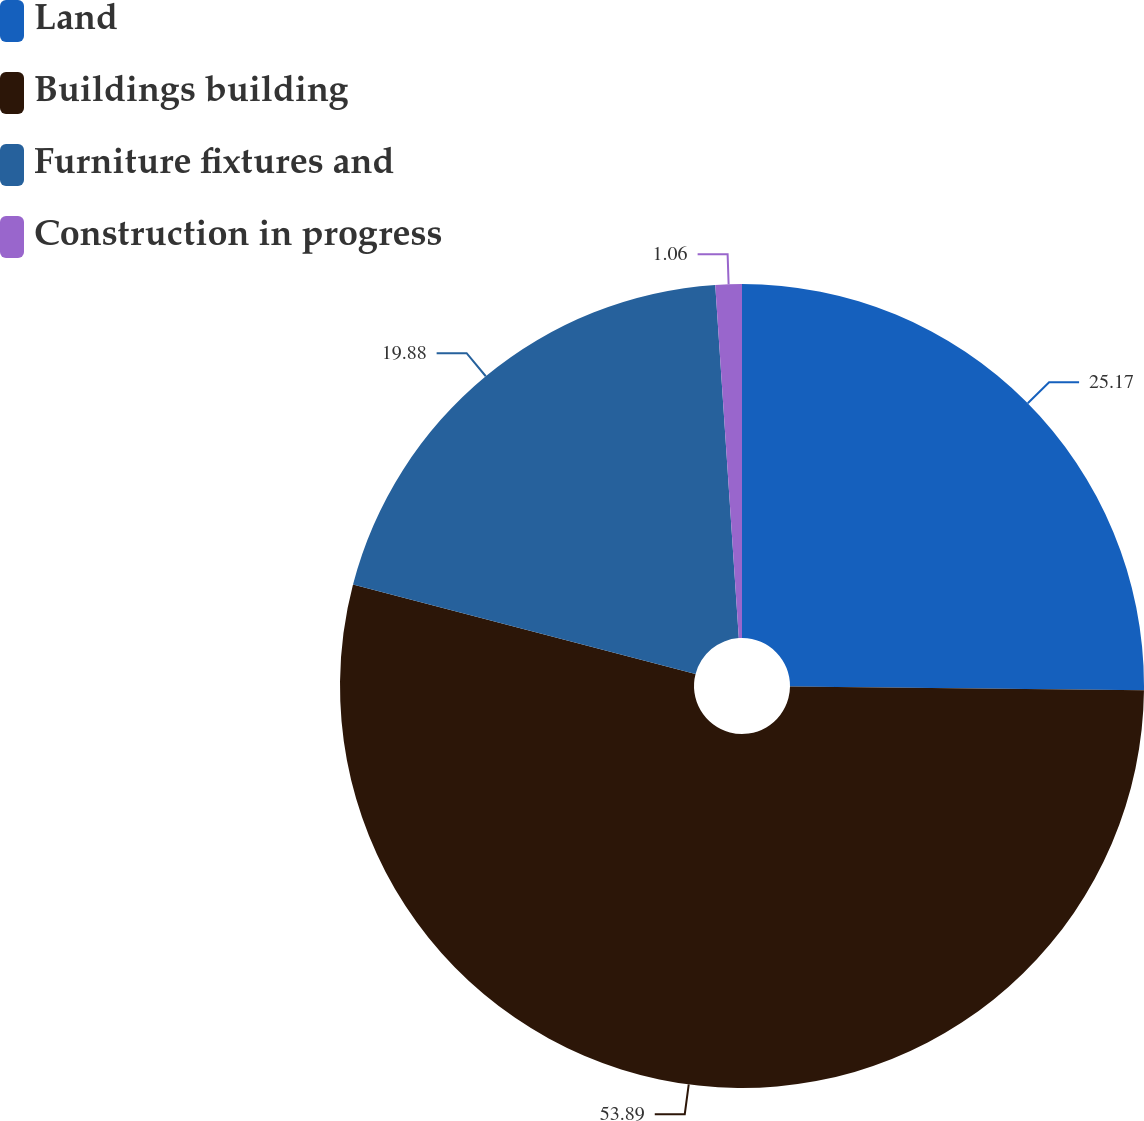<chart> <loc_0><loc_0><loc_500><loc_500><pie_chart><fcel>Land<fcel>Buildings building<fcel>Furniture fixtures and<fcel>Construction in progress<nl><fcel>25.17%<fcel>53.89%<fcel>19.88%<fcel>1.06%<nl></chart> 